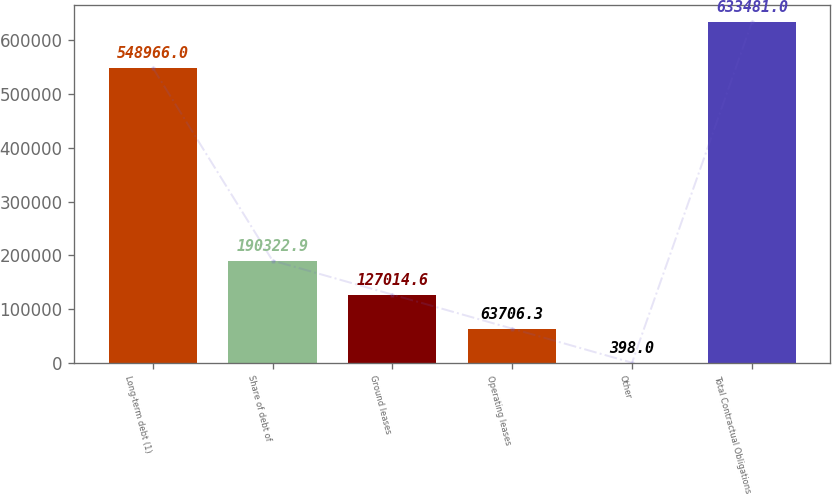<chart> <loc_0><loc_0><loc_500><loc_500><bar_chart><fcel>Long-term debt (1)<fcel>Share of debt of<fcel>Ground leases<fcel>Operating leases<fcel>Other<fcel>Total Contractual Obligations<nl><fcel>548966<fcel>190323<fcel>127015<fcel>63706.3<fcel>398<fcel>633481<nl></chart> 